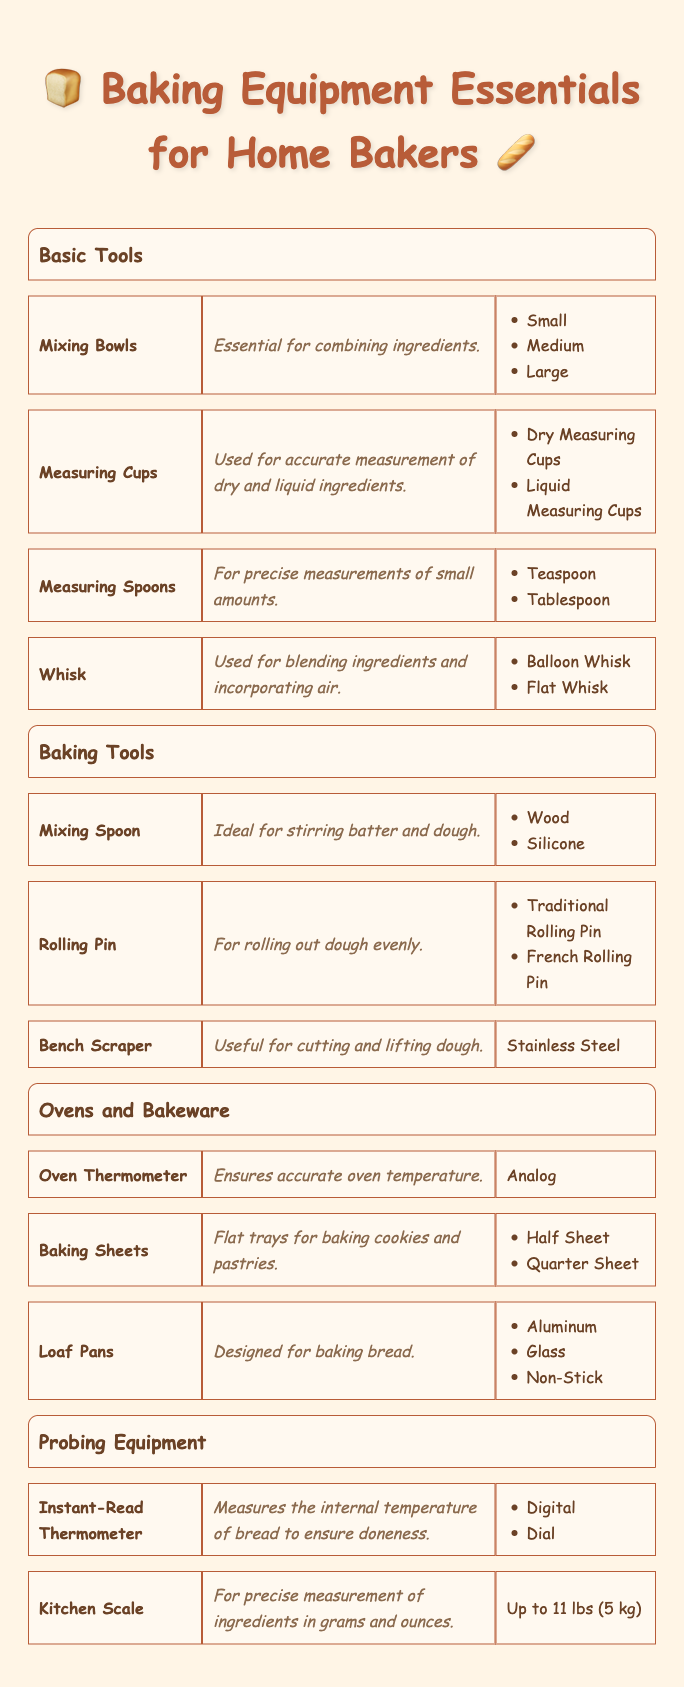What are the sizes of Mixing Bowls? The table lists "Mixing Bowls" under the "Basic Tools" category and mentions the available sizes: Small, Medium, and Large.
Answer: Small, Medium, Large How many types of Measuring Cups are there? In the "Basic Tools" section, "Measuring Cups" are listed with two types: Dry Measuring Cups and Liquid Measuring Cups. Thus, there are two types in total.
Answer: 2 Is a Bench Scraper considered to be made of plastic? The "Bench Scraper" in the "Baking Tools" section specifies that it is made of Stainless Steel, which confirms that it is not made of plastic.
Answer: No What materials are available for Loaf Pans? Under the "Ovens and Bakeware" category, "Loaf Pans" are included, and the table specifies three materials: Aluminum, Glass, and Non-Stick.
Answer: Aluminum, Glass, Non-Stick If I have a Kitchen Scale that measures up to 5 kg, can I use it for this baking? The "Kitchen Scale" listed under "Probing Equipment" has a capacity of up to 11 lbs (5 kg), which means it can indeed be used for baking purposes, especially for precise measurements.
Answer: Yes Which whisk type is used for incorporating air? The table categorizes "Whisk" under "Basic Tools" and describes its function as blending ingredients and incorporating air; the types include Balloon Whisk and Flat Whisk, but both can serve this purpose.
Answer: Balloon Whisk, Flat Whisk How many categories of baking equipment are listed? By analyzing the table, we see four distinct categories: Basic Tools, Baking Tools, Ovens and Bakeware, and Probing Equipment. This indicates there are four categories total.
Answer: 4 What is the primary function of an Oven Thermometer? In the "Ovens and Bakeware" section, the "Oven Thermometer" is described as ensuring accurate oven temperature, which clarifies its primary function.
Answer: Ensures accurate oven temperature Which measuring tool is used for small amounts, and what units does it use? The "Measuring Spoons" under "Basic Tools" is specified for precise measurements of small amounts. The units are listed as Teaspoon and Tablespoon.
Answer: Teaspoon, Tablespoon 